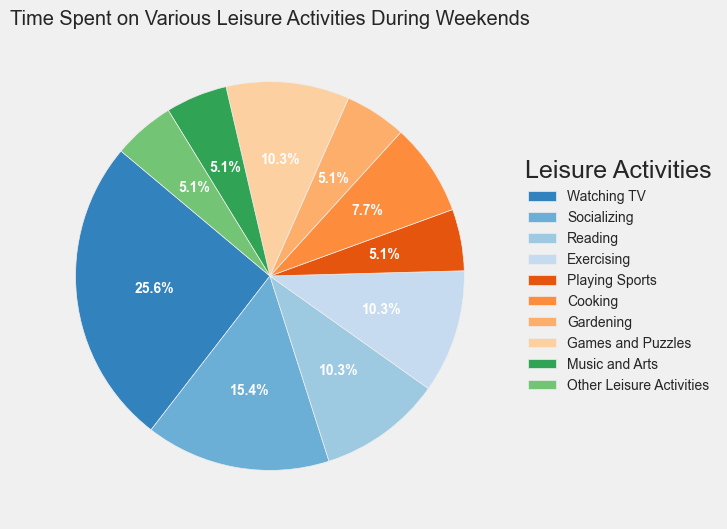What is the percentage of time spent on Watching TV? From the pie chart, find the slice labeled "Watching TV" and check the percentage displayed.
Answer: 27.8% What activity takes up the least amount of time? Identify the smallest slice in the pie chart and look at its label.
Answer: Music and Arts How much total time is spent on physical activities (Exercising + Playing Sports)? Find the slices labeled "Exercising" and "Playing Sports" and add their times: 2 hours + 1 hour = 3 hours.
Answer: 3 hours Which activity takes up more time: Cooking or Gardening? Compare the sizes of the slices labeled "Cooking" and "Gardening," or check the legend if it's clearer.
Answer: Cooking What fraction of total leisure time is spent on Socializing and Games and Puzzles combined? Add their times: Socializing (3 hours) + Games and Puzzles (2 hours) = 5 hours. The total time spent on all activities is 18.5 hours, so 5/18.5 ≈ 0.270 or 27.0%.
Answer: 27.0% How does the time spent on Reading compare to the time spent on Exercising? Compare the slices labeled "Reading" and "Exercising," or check the legend for their time. They both have 2 hours.
Answer: Equal What activity shares the same amount of time as Reading? Find the slices that have the same size as "Reading" or check the legend for matching time values.
Answer: Exercising Which color represents Socializing in the pie chart? Check the legend for "Socializing" and identify its associated color in the pie chart.
Answer: Blue Calculate the average time spent on non-physical activities (Watching TV, Socializing, Reading, Cooking, Gardening, Games and Puzzles, Music and Arts, Other Leisure Activities). Sum their times: 5 + 3 + 2 + 1.5 + 1 + 2 + 1 + 1 = 16.5 hours. There are 8 non-physical activities, so 16.5/8 = 2.06 hours.
Answer: 2.06 hours What is the difference in time spent between the most and least time-consuming activities? The most time-consuming activity is Watching TV (5 hours), and the least is Music and Arts (1 hour). The difference is 5 - 1 = 4 hours.
Answer: 4 hours 